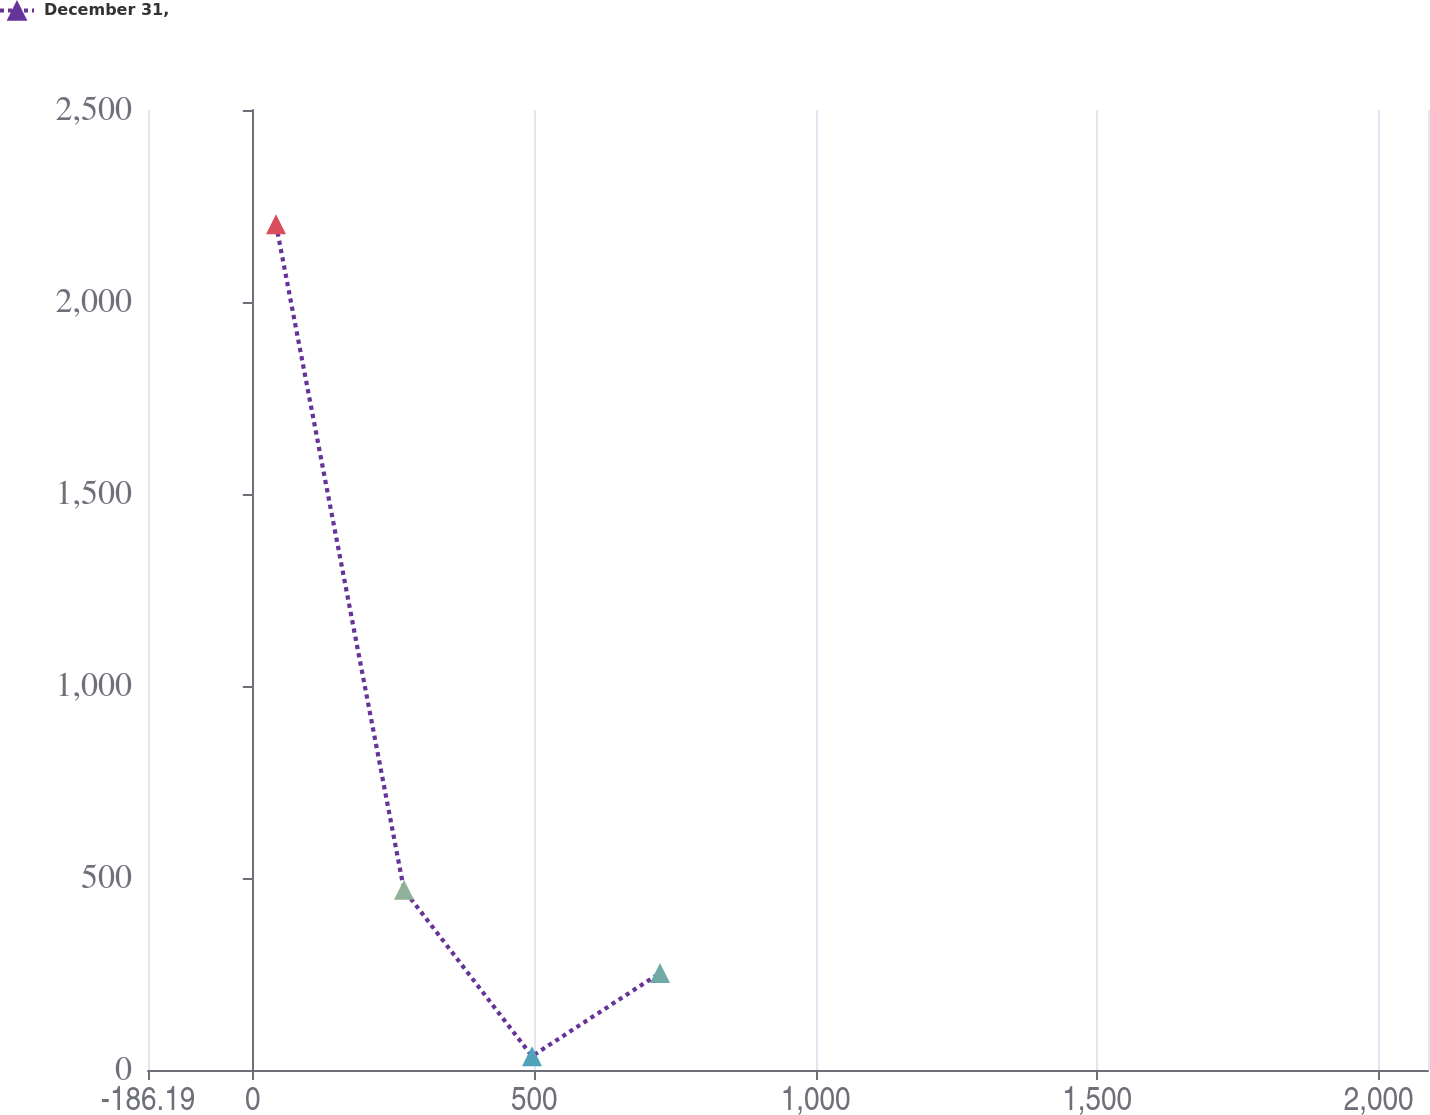Convert chart to OTSL. <chart><loc_0><loc_0><loc_500><loc_500><line_chart><ecel><fcel>December 31,<nl><fcel>41.2<fcel>2202.5<nl><fcel>268.59<fcel>469.27<nl><fcel>495.98<fcel>35.95<nl><fcel>723.37<fcel>252.61<nl><fcel>2315.1<fcel>685.92<nl></chart> 